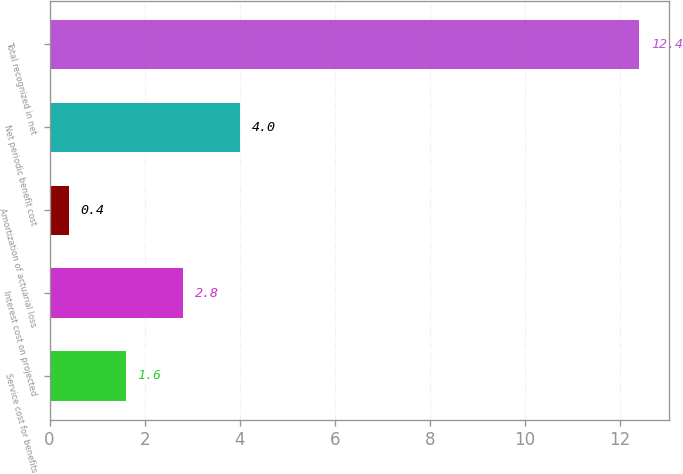<chart> <loc_0><loc_0><loc_500><loc_500><bar_chart><fcel>Service cost for benefits<fcel>Interest cost on projected<fcel>Amortization of actuarial loss<fcel>Net periodic benefit cost<fcel>Total recognized in net<nl><fcel>1.6<fcel>2.8<fcel>0.4<fcel>4<fcel>12.4<nl></chart> 